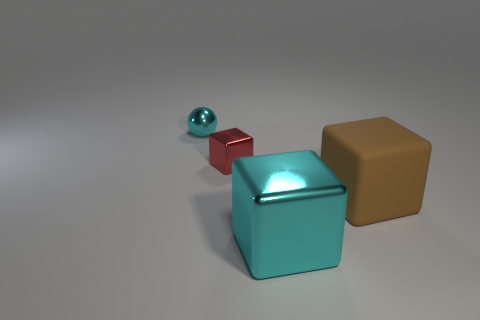Do the brown matte cube and the shiny object in front of the big brown rubber thing have the same size?
Provide a succinct answer. Yes. Is there any other thing that is the same shape as the red metallic object?
Offer a very short reply. Yes. What size is the rubber block?
Your answer should be very brief. Large. Is the number of large brown objects that are in front of the large cyan shiny cube less than the number of cyan spheres?
Provide a succinct answer. Yes. Do the brown rubber thing and the red metal object have the same size?
Ensure brevity in your answer.  No. Is there any other thing that is the same size as the matte object?
Provide a succinct answer. Yes. What color is the big block that is the same material as the cyan ball?
Your response must be concise. Cyan. Are there fewer cyan cubes that are behind the cyan shiny block than large cubes on the left side of the red metallic object?
Give a very brief answer. No. What number of large shiny cubes are the same color as the small ball?
Your answer should be compact. 1. There is a thing that is the same color as the metallic sphere; what is it made of?
Your response must be concise. Metal. 